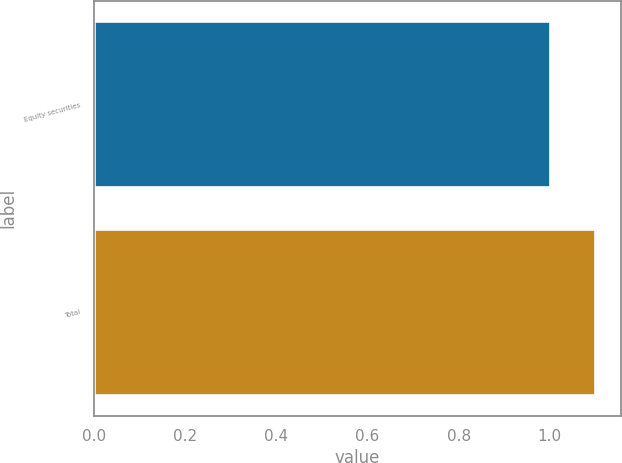Convert chart to OTSL. <chart><loc_0><loc_0><loc_500><loc_500><bar_chart><fcel>Equity securities<fcel>Total<nl><fcel>1<fcel>1.1<nl></chart> 